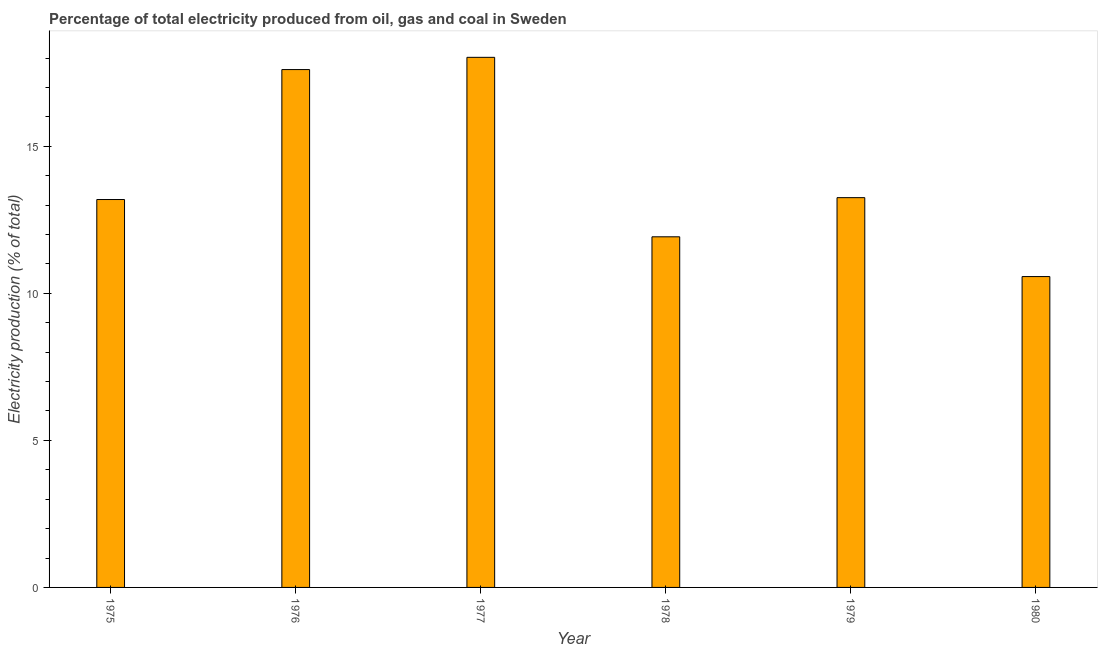Does the graph contain grids?
Your answer should be compact. No. What is the title of the graph?
Give a very brief answer. Percentage of total electricity produced from oil, gas and coal in Sweden. What is the label or title of the Y-axis?
Your answer should be very brief. Electricity production (% of total). What is the electricity production in 1975?
Offer a very short reply. 13.19. Across all years, what is the maximum electricity production?
Ensure brevity in your answer.  18.03. Across all years, what is the minimum electricity production?
Your response must be concise. 10.57. In which year was the electricity production minimum?
Provide a succinct answer. 1980. What is the sum of the electricity production?
Provide a short and direct response. 84.57. What is the difference between the electricity production in 1975 and 1977?
Keep it short and to the point. -4.83. What is the average electricity production per year?
Provide a succinct answer. 14.1. What is the median electricity production?
Provide a short and direct response. 13.22. In how many years, is the electricity production greater than 5 %?
Offer a terse response. 6. Do a majority of the years between 1977 and 1975 (inclusive) have electricity production greater than 3 %?
Offer a terse response. Yes. What is the ratio of the electricity production in 1978 to that in 1980?
Keep it short and to the point. 1.13. Is the electricity production in 1975 less than that in 1976?
Your answer should be compact. Yes. Is the difference between the electricity production in 1977 and 1978 greater than the difference between any two years?
Offer a terse response. No. What is the difference between the highest and the second highest electricity production?
Provide a short and direct response. 0.42. What is the difference between the highest and the lowest electricity production?
Your answer should be very brief. 7.46. How many bars are there?
Give a very brief answer. 6. Are all the bars in the graph horizontal?
Ensure brevity in your answer.  No. What is the difference between two consecutive major ticks on the Y-axis?
Offer a terse response. 5. What is the Electricity production (% of total) of 1975?
Make the answer very short. 13.19. What is the Electricity production (% of total) of 1976?
Provide a succinct answer. 17.61. What is the Electricity production (% of total) of 1977?
Your response must be concise. 18.03. What is the Electricity production (% of total) in 1978?
Give a very brief answer. 11.92. What is the Electricity production (% of total) in 1979?
Give a very brief answer. 13.25. What is the Electricity production (% of total) in 1980?
Keep it short and to the point. 10.57. What is the difference between the Electricity production (% of total) in 1975 and 1976?
Offer a terse response. -4.42. What is the difference between the Electricity production (% of total) in 1975 and 1977?
Your response must be concise. -4.84. What is the difference between the Electricity production (% of total) in 1975 and 1978?
Your response must be concise. 1.27. What is the difference between the Electricity production (% of total) in 1975 and 1979?
Your answer should be very brief. -0.06. What is the difference between the Electricity production (% of total) in 1975 and 1980?
Your response must be concise. 2.62. What is the difference between the Electricity production (% of total) in 1976 and 1977?
Keep it short and to the point. -0.42. What is the difference between the Electricity production (% of total) in 1976 and 1978?
Make the answer very short. 5.69. What is the difference between the Electricity production (% of total) in 1976 and 1979?
Ensure brevity in your answer.  4.36. What is the difference between the Electricity production (% of total) in 1976 and 1980?
Offer a very short reply. 7.04. What is the difference between the Electricity production (% of total) in 1977 and 1978?
Provide a succinct answer. 6.1. What is the difference between the Electricity production (% of total) in 1977 and 1979?
Provide a succinct answer. 4.77. What is the difference between the Electricity production (% of total) in 1977 and 1980?
Offer a terse response. 7.46. What is the difference between the Electricity production (% of total) in 1978 and 1979?
Your answer should be very brief. -1.33. What is the difference between the Electricity production (% of total) in 1978 and 1980?
Keep it short and to the point. 1.35. What is the difference between the Electricity production (% of total) in 1979 and 1980?
Offer a terse response. 2.68. What is the ratio of the Electricity production (% of total) in 1975 to that in 1976?
Ensure brevity in your answer.  0.75. What is the ratio of the Electricity production (% of total) in 1975 to that in 1977?
Give a very brief answer. 0.73. What is the ratio of the Electricity production (% of total) in 1975 to that in 1978?
Your answer should be compact. 1.11. What is the ratio of the Electricity production (% of total) in 1975 to that in 1979?
Provide a succinct answer. 0.99. What is the ratio of the Electricity production (% of total) in 1975 to that in 1980?
Your answer should be compact. 1.25. What is the ratio of the Electricity production (% of total) in 1976 to that in 1978?
Ensure brevity in your answer.  1.48. What is the ratio of the Electricity production (% of total) in 1976 to that in 1979?
Your answer should be compact. 1.33. What is the ratio of the Electricity production (% of total) in 1976 to that in 1980?
Ensure brevity in your answer.  1.67. What is the ratio of the Electricity production (% of total) in 1977 to that in 1978?
Keep it short and to the point. 1.51. What is the ratio of the Electricity production (% of total) in 1977 to that in 1979?
Keep it short and to the point. 1.36. What is the ratio of the Electricity production (% of total) in 1977 to that in 1980?
Keep it short and to the point. 1.71. What is the ratio of the Electricity production (% of total) in 1978 to that in 1980?
Your answer should be very brief. 1.13. What is the ratio of the Electricity production (% of total) in 1979 to that in 1980?
Offer a very short reply. 1.25. 